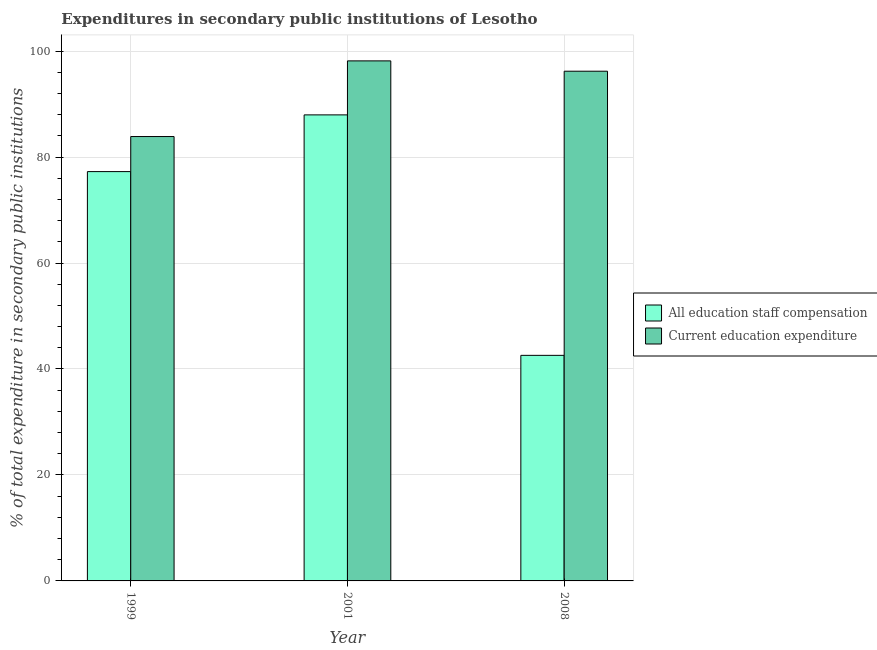How many different coloured bars are there?
Your answer should be compact. 2. How many groups of bars are there?
Ensure brevity in your answer.  3. Are the number of bars per tick equal to the number of legend labels?
Your answer should be compact. Yes. Are the number of bars on each tick of the X-axis equal?
Give a very brief answer. Yes. How many bars are there on the 3rd tick from the left?
Keep it short and to the point. 2. How many bars are there on the 1st tick from the right?
Your answer should be very brief. 2. What is the expenditure in education in 1999?
Provide a short and direct response. 83.87. Across all years, what is the maximum expenditure in staff compensation?
Provide a short and direct response. 87.96. Across all years, what is the minimum expenditure in education?
Make the answer very short. 83.87. In which year was the expenditure in education maximum?
Keep it short and to the point. 2001. In which year was the expenditure in staff compensation minimum?
Your answer should be very brief. 2008. What is the total expenditure in education in the graph?
Your answer should be compact. 278.22. What is the difference between the expenditure in staff compensation in 1999 and that in 2008?
Provide a short and direct response. 34.68. What is the difference between the expenditure in education in 2001 and the expenditure in staff compensation in 2008?
Offer a terse response. 1.95. What is the average expenditure in education per year?
Make the answer very short. 92.74. In the year 1999, what is the difference between the expenditure in education and expenditure in staff compensation?
Your response must be concise. 0. What is the ratio of the expenditure in staff compensation in 1999 to that in 2008?
Ensure brevity in your answer.  1.81. Is the expenditure in staff compensation in 2001 less than that in 2008?
Make the answer very short. No. What is the difference between the highest and the second highest expenditure in education?
Your response must be concise. 1.95. What is the difference between the highest and the lowest expenditure in education?
Offer a terse response. 14.28. In how many years, is the expenditure in education greater than the average expenditure in education taken over all years?
Give a very brief answer. 2. What does the 2nd bar from the left in 2001 represents?
Keep it short and to the point. Current education expenditure. What does the 2nd bar from the right in 2008 represents?
Your response must be concise. All education staff compensation. Are all the bars in the graph horizontal?
Your answer should be very brief. No. What is the difference between two consecutive major ticks on the Y-axis?
Give a very brief answer. 20. Are the values on the major ticks of Y-axis written in scientific E-notation?
Provide a succinct answer. No. Does the graph contain any zero values?
Provide a short and direct response. No. Does the graph contain grids?
Keep it short and to the point. Yes. How are the legend labels stacked?
Ensure brevity in your answer.  Vertical. What is the title of the graph?
Provide a succinct answer. Expenditures in secondary public institutions of Lesotho. What is the label or title of the Y-axis?
Offer a very short reply. % of total expenditure in secondary public institutions. What is the % of total expenditure in secondary public institutions of All education staff compensation in 1999?
Your answer should be compact. 77.25. What is the % of total expenditure in secondary public institutions in Current education expenditure in 1999?
Your answer should be very brief. 83.87. What is the % of total expenditure in secondary public institutions in All education staff compensation in 2001?
Make the answer very short. 87.96. What is the % of total expenditure in secondary public institutions in Current education expenditure in 2001?
Offer a very short reply. 98.15. What is the % of total expenditure in secondary public institutions of All education staff compensation in 2008?
Your response must be concise. 42.57. What is the % of total expenditure in secondary public institutions in Current education expenditure in 2008?
Make the answer very short. 96.2. Across all years, what is the maximum % of total expenditure in secondary public institutions in All education staff compensation?
Provide a succinct answer. 87.96. Across all years, what is the maximum % of total expenditure in secondary public institutions of Current education expenditure?
Make the answer very short. 98.15. Across all years, what is the minimum % of total expenditure in secondary public institutions in All education staff compensation?
Offer a terse response. 42.57. Across all years, what is the minimum % of total expenditure in secondary public institutions in Current education expenditure?
Your response must be concise. 83.87. What is the total % of total expenditure in secondary public institutions in All education staff compensation in the graph?
Ensure brevity in your answer.  207.78. What is the total % of total expenditure in secondary public institutions of Current education expenditure in the graph?
Make the answer very short. 278.22. What is the difference between the % of total expenditure in secondary public institutions of All education staff compensation in 1999 and that in 2001?
Provide a short and direct response. -10.71. What is the difference between the % of total expenditure in secondary public institutions of Current education expenditure in 1999 and that in 2001?
Your answer should be compact. -14.28. What is the difference between the % of total expenditure in secondary public institutions in All education staff compensation in 1999 and that in 2008?
Give a very brief answer. 34.68. What is the difference between the % of total expenditure in secondary public institutions of Current education expenditure in 1999 and that in 2008?
Ensure brevity in your answer.  -12.33. What is the difference between the % of total expenditure in secondary public institutions of All education staff compensation in 2001 and that in 2008?
Provide a short and direct response. 45.39. What is the difference between the % of total expenditure in secondary public institutions of Current education expenditure in 2001 and that in 2008?
Keep it short and to the point. 1.95. What is the difference between the % of total expenditure in secondary public institutions in All education staff compensation in 1999 and the % of total expenditure in secondary public institutions in Current education expenditure in 2001?
Keep it short and to the point. -20.9. What is the difference between the % of total expenditure in secondary public institutions of All education staff compensation in 1999 and the % of total expenditure in secondary public institutions of Current education expenditure in 2008?
Make the answer very short. -18.95. What is the difference between the % of total expenditure in secondary public institutions of All education staff compensation in 2001 and the % of total expenditure in secondary public institutions of Current education expenditure in 2008?
Provide a short and direct response. -8.24. What is the average % of total expenditure in secondary public institutions in All education staff compensation per year?
Your answer should be compact. 69.26. What is the average % of total expenditure in secondary public institutions in Current education expenditure per year?
Give a very brief answer. 92.74. In the year 1999, what is the difference between the % of total expenditure in secondary public institutions of All education staff compensation and % of total expenditure in secondary public institutions of Current education expenditure?
Keep it short and to the point. -6.62. In the year 2001, what is the difference between the % of total expenditure in secondary public institutions of All education staff compensation and % of total expenditure in secondary public institutions of Current education expenditure?
Provide a short and direct response. -10.19. In the year 2008, what is the difference between the % of total expenditure in secondary public institutions in All education staff compensation and % of total expenditure in secondary public institutions in Current education expenditure?
Your answer should be very brief. -53.63. What is the ratio of the % of total expenditure in secondary public institutions of All education staff compensation in 1999 to that in 2001?
Keep it short and to the point. 0.88. What is the ratio of the % of total expenditure in secondary public institutions of Current education expenditure in 1999 to that in 2001?
Keep it short and to the point. 0.85. What is the ratio of the % of total expenditure in secondary public institutions in All education staff compensation in 1999 to that in 2008?
Give a very brief answer. 1.81. What is the ratio of the % of total expenditure in secondary public institutions of Current education expenditure in 1999 to that in 2008?
Your answer should be compact. 0.87. What is the ratio of the % of total expenditure in secondary public institutions of All education staff compensation in 2001 to that in 2008?
Provide a succinct answer. 2.07. What is the ratio of the % of total expenditure in secondary public institutions of Current education expenditure in 2001 to that in 2008?
Your response must be concise. 1.02. What is the difference between the highest and the second highest % of total expenditure in secondary public institutions of All education staff compensation?
Offer a terse response. 10.71. What is the difference between the highest and the second highest % of total expenditure in secondary public institutions of Current education expenditure?
Give a very brief answer. 1.95. What is the difference between the highest and the lowest % of total expenditure in secondary public institutions of All education staff compensation?
Give a very brief answer. 45.39. What is the difference between the highest and the lowest % of total expenditure in secondary public institutions in Current education expenditure?
Give a very brief answer. 14.28. 